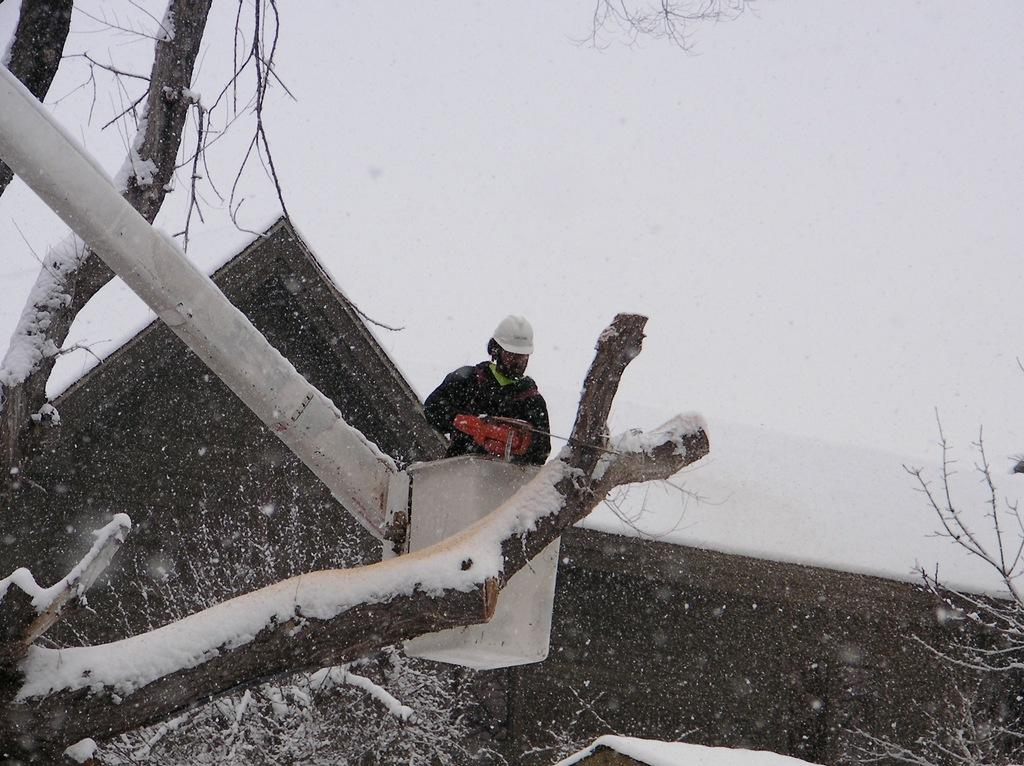What is the man in the image doing? The man is in a crane, which suggests he is working at a height. What is the man holding in the image? The man is holding a tool, which indicates he is performing a task. What safety equipment is the man wearing? The man is wearing a helmet for safety. What type of environment can be seen in the image? There are trees visible in the image, which suggests a natural setting. What weather condition is present in the image? There is snow in the image, indicating a cold environment. What is the color of the background in the image? The background appears white, likely due to the snow and sky. Can you tell me how many spoons are visible in the image? There are no spoons present in the image. What type of crook is the man trying to catch in the image? There is no crook or any indication of criminal activity in the image. 